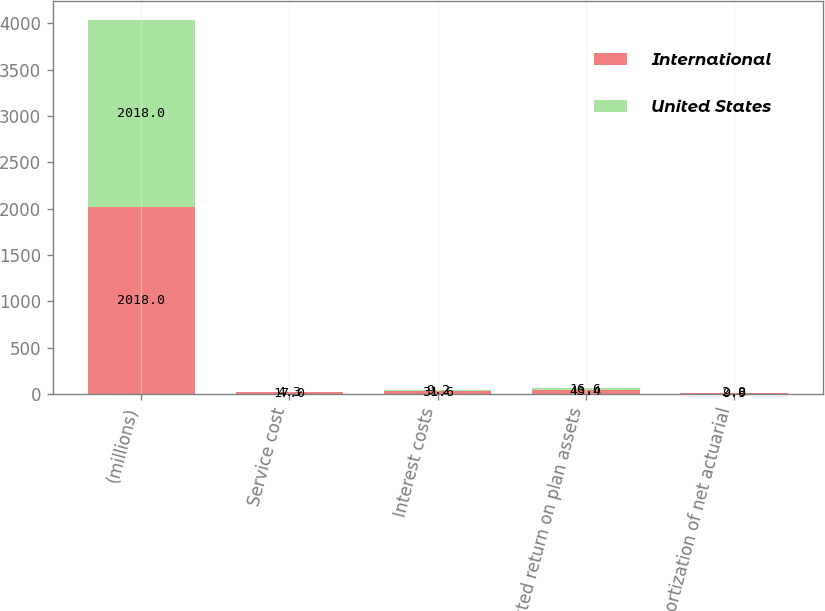Convert chart. <chart><loc_0><loc_0><loc_500><loc_500><stacked_bar_chart><ecel><fcel>(millions)<fcel>Service cost<fcel>Interest costs<fcel>Expected return on plan assets<fcel>Amortization of net actuarial<nl><fcel>International<fcel>2018<fcel>17<fcel>31.6<fcel>43.4<fcel>9.9<nl><fcel>United States<fcel>2018<fcel>4.3<fcel>9.2<fcel>16.6<fcel>2.8<nl></chart> 